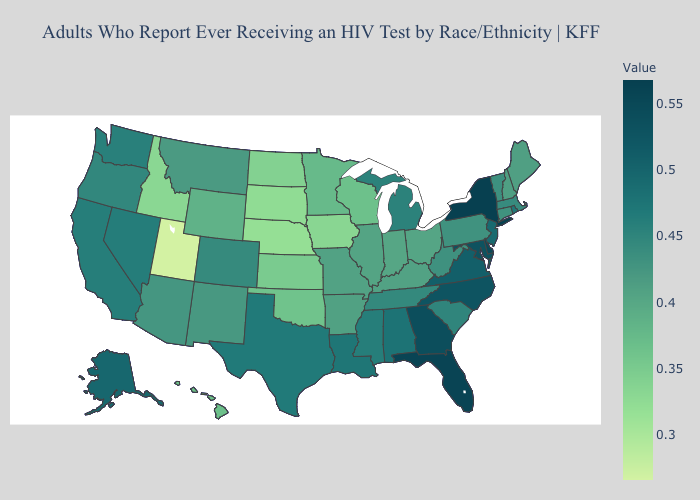Which states have the highest value in the USA?
Quick response, please. New York. Is the legend a continuous bar?
Concise answer only. Yes. Among the states that border Montana , does South Dakota have the lowest value?
Give a very brief answer. Yes. Among the states that border New Jersey , which have the highest value?
Answer briefly. New York. Is the legend a continuous bar?
Short answer required. Yes. Among the states that border Wisconsin , which have the highest value?
Concise answer only. Michigan. Does Nebraska have the lowest value in the MidWest?
Answer briefly. Yes. 